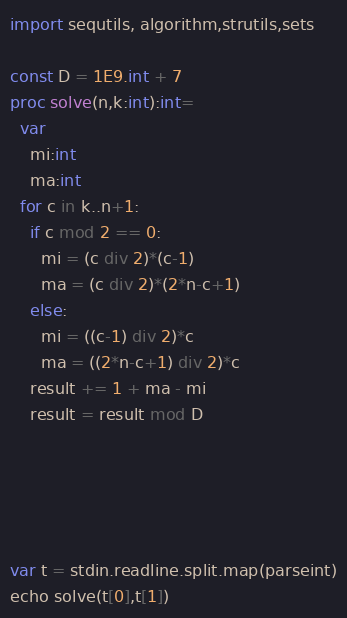<code> <loc_0><loc_0><loc_500><loc_500><_Nim_>import sequtils, algorithm,strutils,sets

const D = 1E9.int + 7
proc solve(n,k:int):int=
  var
    mi:int
    ma:int
  for c in k..n+1:
    if c mod 2 == 0:
      mi = (c div 2)*(c-1)
      ma = (c div 2)*(2*n-c+1)
    else:
      mi = ((c-1) div 2)*c
      ma = ((2*n-c+1) div 2)*c
    result += 1 + ma - mi
    result = result mod D





var t = stdin.readline.split.map(parseint)
echo solve(t[0],t[1])</code> 